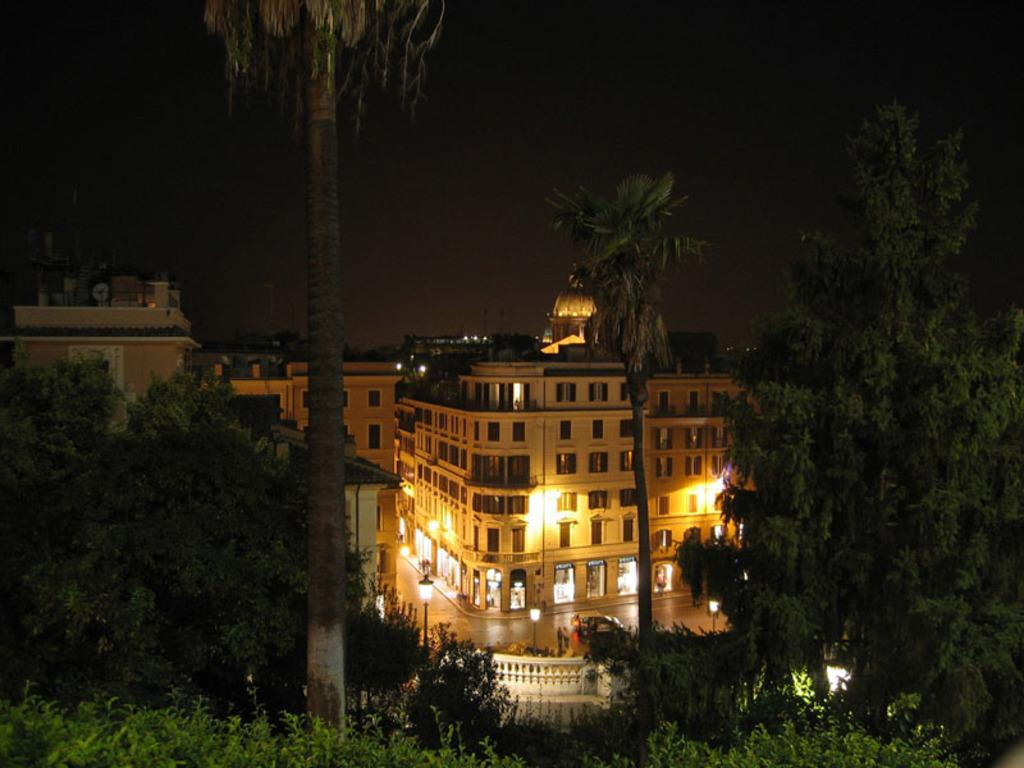What type of structures can be seen in the image? There are buildings in the image. What natural elements are present in the image? There are trees in the image. What artificial elements can be seen in the image? There are lights and poles in the image. What type of house can be seen in the aftermath of the storm in the image? There is no house or storm present in the image; it only features buildings, trees, lights, and poles. 